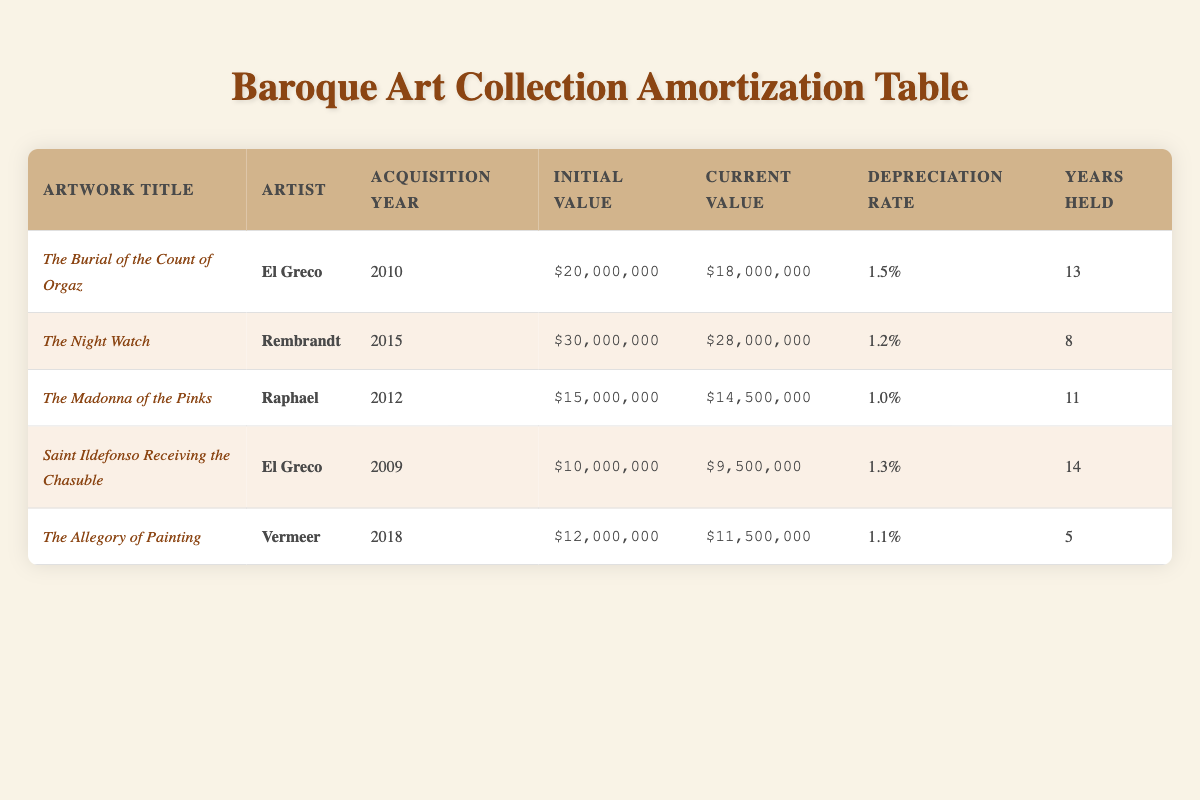What is the current value of "The Burial of the Count of Orgaz"? The current value of this artwork can be found in the "Current Value" column corresponding to the row containing "The Burial of the Count of Orgaz". It states $18,000,000.
Answer: $18,000,000 Which artwork has the highest initial value? To find this, we compare the values in the "Initial Value" column. The initial value of "The Night Watch" is $30,000,000, which is higher than all other artworks listed.
Answer: $30,000,000 How much did "Saint Ildefonso Receiving the Chasuble" depreciate in value? The depreciation in value is calculated by subtracting the "Current Value" from the "Initial Value" for "Saint Ildefonso Receiving the Chasuble". The calculation is ($10,000,000 - $9,500,000) = $500,000.
Answer: $500,000 What is the average depreciation rate of the artworks listed? We sum up the depreciation rates: (1.5 + 1.2 + 1.0 + 1.3 + 1.1) = 6.1. There are 5 artworks, so dividing the total by 5 gives us an average depreciation rate of 6.1 / 5 = 1.22.
Answer: 1.22 Did "The Madonna of the Pinks" appreciate in value since its acquisition? We check the "Initial Value" and the "Current Value" for "The Madonna of the Pinks". The initial value was $15,000,000 and the current value is $14,500,000, indicating that it depreciated, not appreciated.
Answer: No Which artwork has the least years held? The "Years Held" column shows that "The Allegory of Painting" has the least years held at 5 years, compared to others.
Answer: 5 What is the difference in current value between "The Night Watch" and "The Allegory of Painting"? To find the difference, we subtract the current value of "The Allegory of Painting" from that of "The Night Watch": ($28,000,000 - $11,500,000) = $16,500,000.
Answer: $16,500,000 Which artist has two artworks in this table? By looking through the "Artist" column, we see that "El Greco" appears twice (for "The Burial of the Count of Orgaz" and "Saint Ildefonso Receiving the Chasuble").
Answer: El Greco What is the total current value of all artworks in the table? We sum the "Current Value" of each artwork: $18,000,000 + $28,000,000 + $14,500,000 + $9,500,000 + $11,500,000 = $81,500,000.
Answer: $81,500,000 